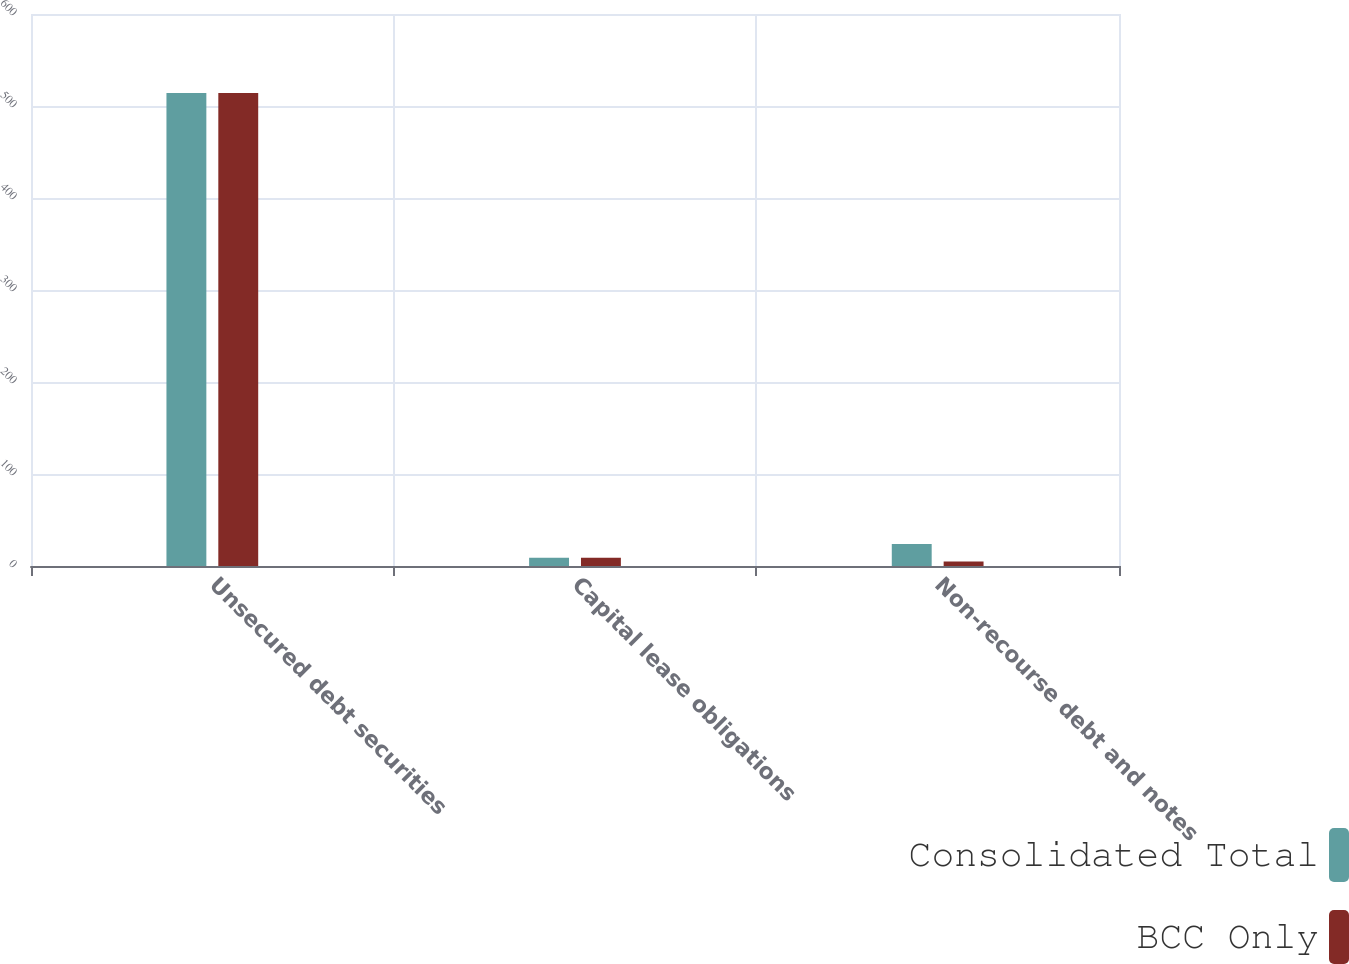<chart> <loc_0><loc_0><loc_500><loc_500><stacked_bar_chart><ecel><fcel>Unsecured debt securities<fcel>Capital lease obligations<fcel>Non-recourse debt and notes<nl><fcel>Consolidated Total<fcel>514<fcel>9<fcel>24<nl><fcel>BCC Only<fcel>514<fcel>9<fcel>5<nl></chart> 